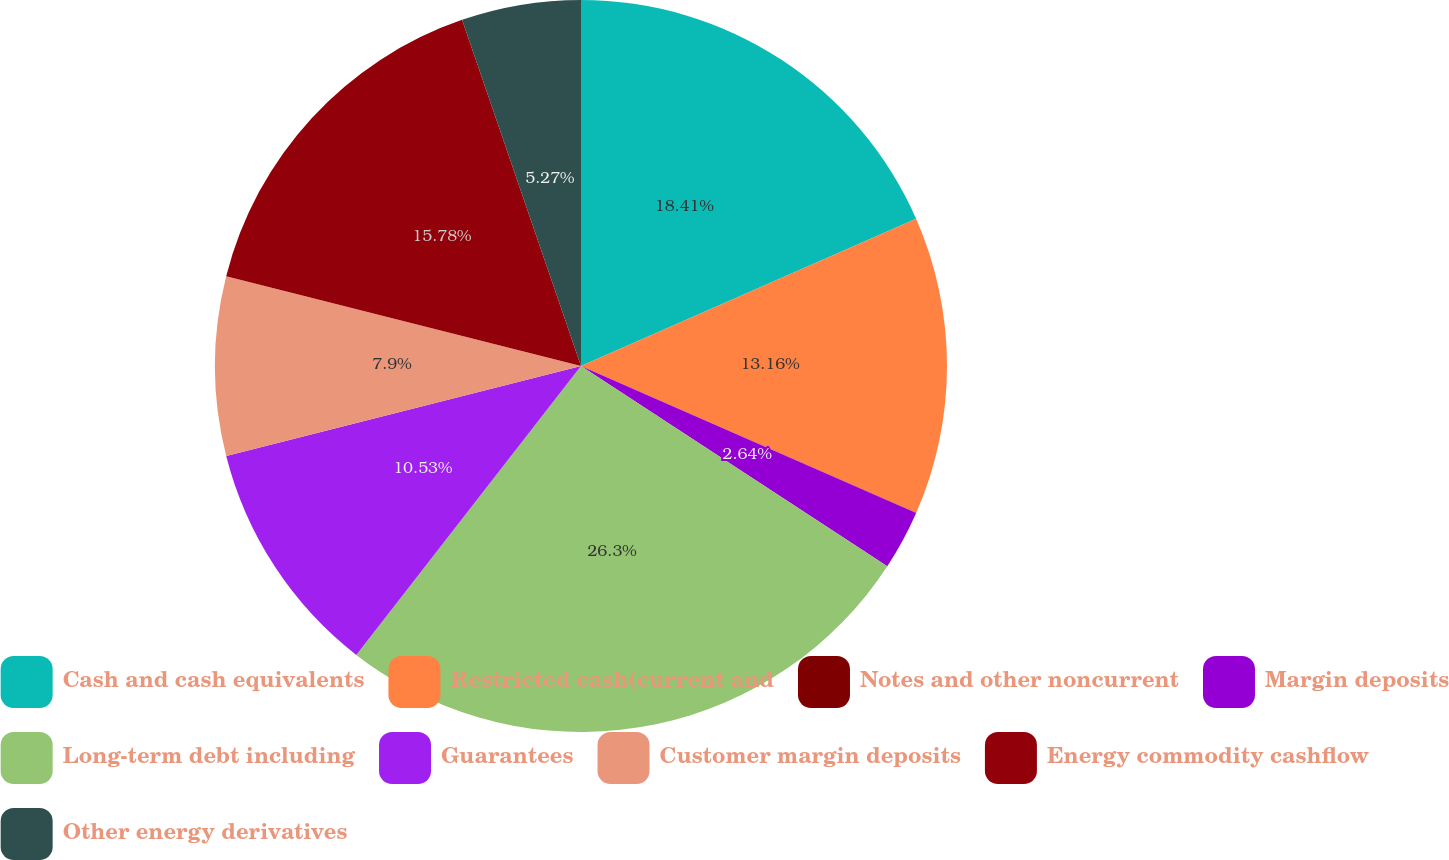Convert chart. <chart><loc_0><loc_0><loc_500><loc_500><pie_chart><fcel>Cash and cash equivalents<fcel>Restricted cash(current and<fcel>Notes and other noncurrent<fcel>Margin deposits<fcel>Long-term debt including<fcel>Guarantees<fcel>Customer margin deposits<fcel>Energy commodity cashflow<fcel>Other energy derivatives<nl><fcel>18.42%<fcel>13.16%<fcel>0.01%<fcel>2.64%<fcel>26.31%<fcel>10.53%<fcel>7.9%<fcel>15.79%<fcel>5.27%<nl></chart> 